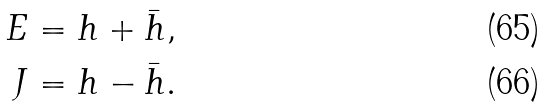<formula> <loc_0><loc_0><loc_500><loc_500>E & = h + \bar { h } , \\ J & = h - \bar { h } .</formula> 